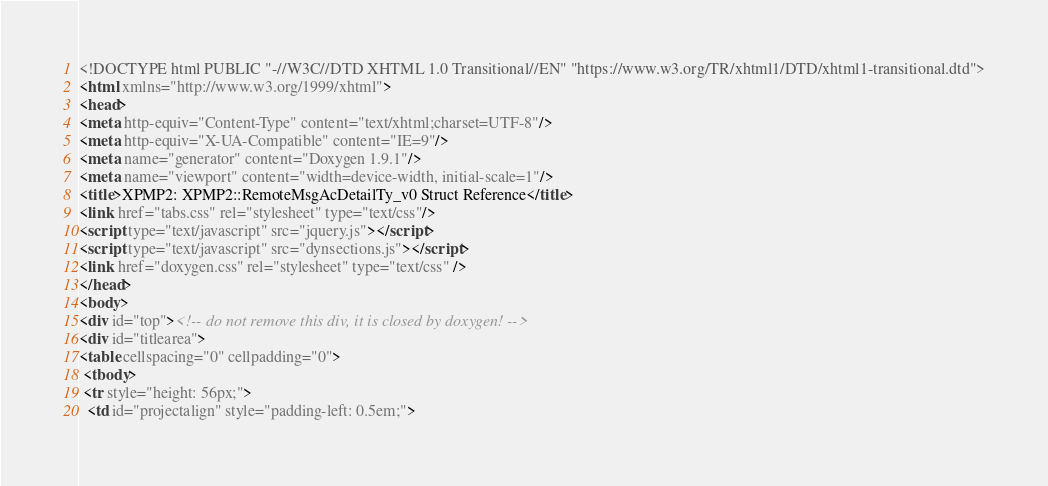Convert code to text. <code><loc_0><loc_0><loc_500><loc_500><_HTML_><!DOCTYPE html PUBLIC "-//W3C//DTD XHTML 1.0 Transitional//EN" "https://www.w3.org/TR/xhtml1/DTD/xhtml1-transitional.dtd">
<html xmlns="http://www.w3.org/1999/xhtml">
<head>
<meta http-equiv="Content-Type" content="text/xhtml;charset=UTF-8"/>
<meta http-equiv="X-UA-Compatible" content="IE=9"/>
<meta name="generator" content="Doxygen 1.9.1"/>
<meta name="viewport" content="width=device-width, initial-scale=1"/>
<title>XPMP2: XPMP2::RemoteMsgAcDetailTy_v0 Struct Reference</title>
<link href="tabs.css" rel="stylesheet" type="text/css"/>
<script type="text/javascript" src="jquery.js"></script>
<script type="text/javascript" src="dynsections.js"></script>
<link href="doxygen.css" rel="stylesheet" type="text/css" />
</head>
<body>
<div id="top"><!-- do not remove this div, it is closed by doxygen! -->
<div id="titlearea">
<table cellspacing="0" cellpadding="0">
 <tbody>
 <tr style="height: 56px;">
  <td id="projectalign" style="padding-left: 0.5em;"></code> 